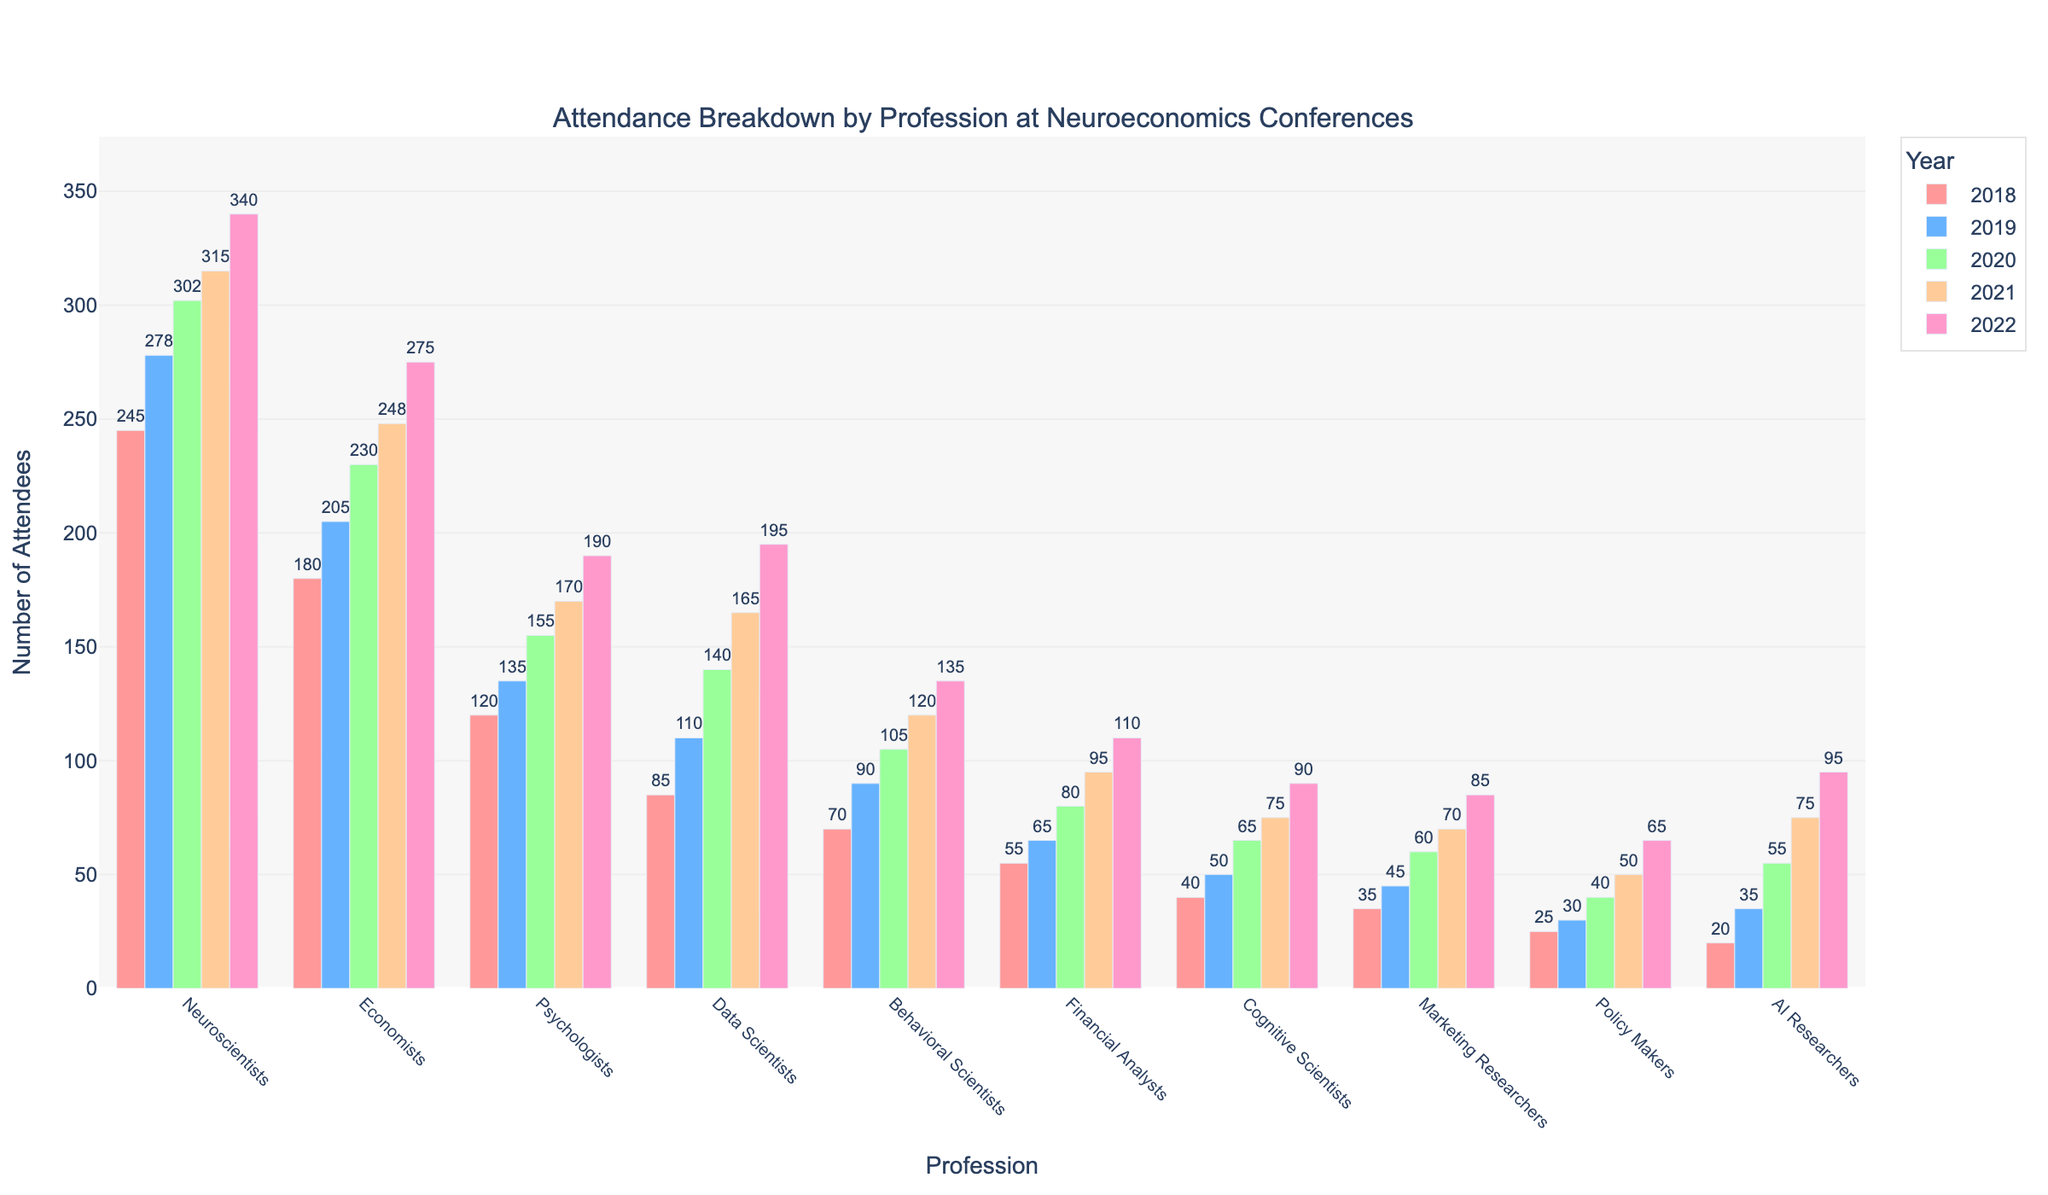What is the profession with the highest attendance in 2022? To determine the profession with the highest attendance in 2022, look at the height of the bars for each profession within the 2022 group. The tallest bar will represent the profession with the highest attendance.
Answer: Neuroscientists How has the attendance of AI Researchers changed from 2018 to 2022? Examine the bars representing AI Researchers across the years 2018 to 2022. Note the numeric values for each year and observe the trend.
Answer: Increased Which profession showed the greatest increase in attendance from 2018 to 2022? Calculate the difference in attendance for each profession between 2018 and 2022, and determine which profession has the highest increase. For example, for Neuroscientists, the increase is 340 - 245 = 95. Repeat for all professions and compare the values.
Answer: AI Researchers How many more Data Scientists attended compared to Financial Analysts in 2021? Look at the attendance numbers for Data Scientists and Financial Analysts in 2021. Subtract the number of Financial Analysts from the number of Data Scientists (165 - 95).
Answer: 70 Was the attendance of Economists greater than that of Psychologists in 2019? Compare the height of the bars for Economists and Psychologists in 2019. Alternatively, compare their values directly: 205 for Economists and 135 for Psychologists.
Answer: Yes What's the average annual attendance of Cognitive Scientists over the 5 years? Sum the attendance numbers of Cognitive Scientists for each year and then divide by 5. (40 + 50 + 65 + 75 + 90) / 5 = 64.
Answer: 64 Which profession had the least number of attendees in 2018 and how much was it? Identify the shortest bar among all professions for the year 2018. Compare the values directly to find the least number.
Answer: AI Researchers, 20 Did any profession have more attendees in 2020 than Neuroscientists? Compare the attendance number of Neuroscientists in 2020 (302) with other professions' numbers in the same year.
Answer: No What is the total attendance of Marketing Researchers over the 5 years? Add the attendance numbers for Marketing Researchers from each year. 35 + 45 + 60 + 70 + 85 = 295.
Answer: 295 How does the trend of attendance for Behavioral Scientists compare from 2018 to 2022? Observe and describe how the attendance for Behavioral Scientists changes each year from 2018 to 2022. Compare the height of the bars to understand the pattern.
Answer: Increasing 